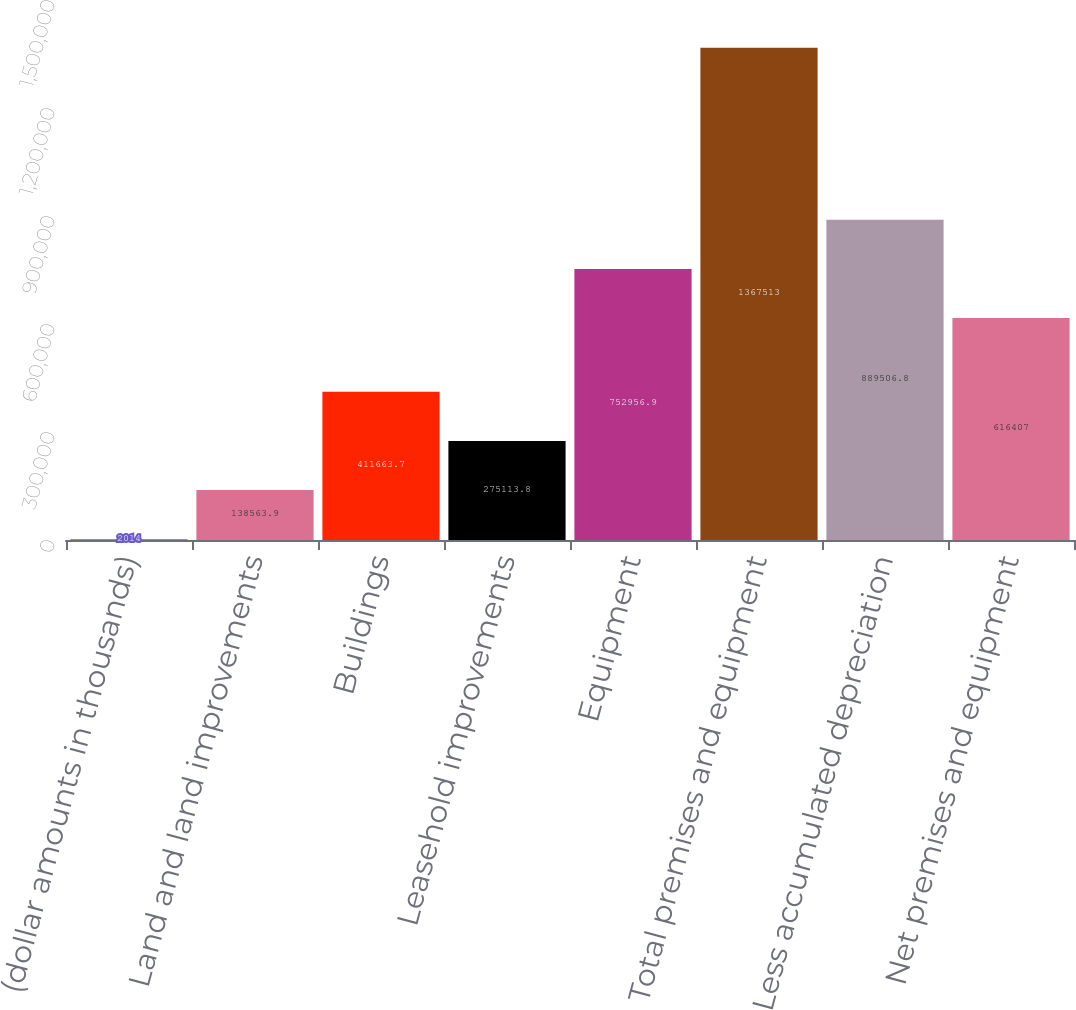Convert chart. <chart><loc_0><loc_0><loc_500><loc_500><bar_chart><fcel>(dollar amounts in thousands)<fcel>Land and land improvements<fcel>Buildings<fcel>Leasehold improvements<fcel>Equipment<fcel>Total premises and equipment<fcel>Less accumulated depreciation<fcel>Net premises and equipment<nl><fcel>2014<fcel>138564<fcel>411664<fcel>275114<fcel>752957<fcel>1.36751e+06<fcel>889507<fcel>616407<nl></chart> 